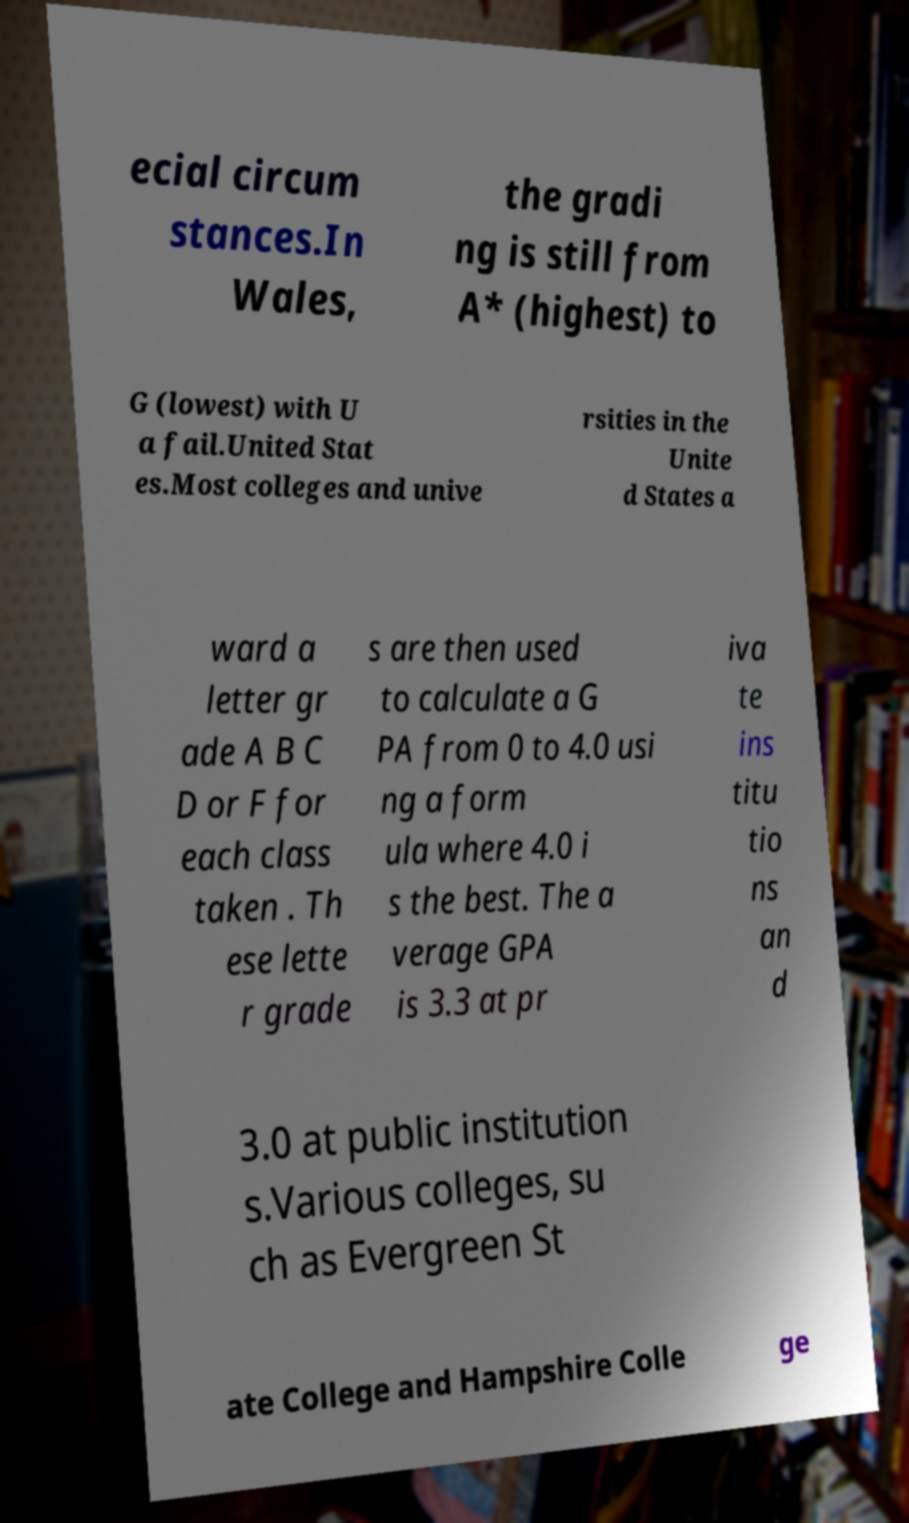Could you extract and type out the text from this image? ecial circum stances.In Wales, the gradi ng is still from A* (highest) to G (lowest) with U a fail.United Stat es.Most colleges and unive rsities in the Unite d States a ward a letter gr ade A B C D or F for each class taken . Th ese lette r grade s are then used to calculate a G PA from 0 to 4.0 usi ng a form ula where 4.0 i s the best. The a verage GPA is 3.3 at pr iva te ins titu tio ns an d 3.0 at public institution s.Various colleges, su ch as Evergreen St ate College and Hampshire Colle ge 